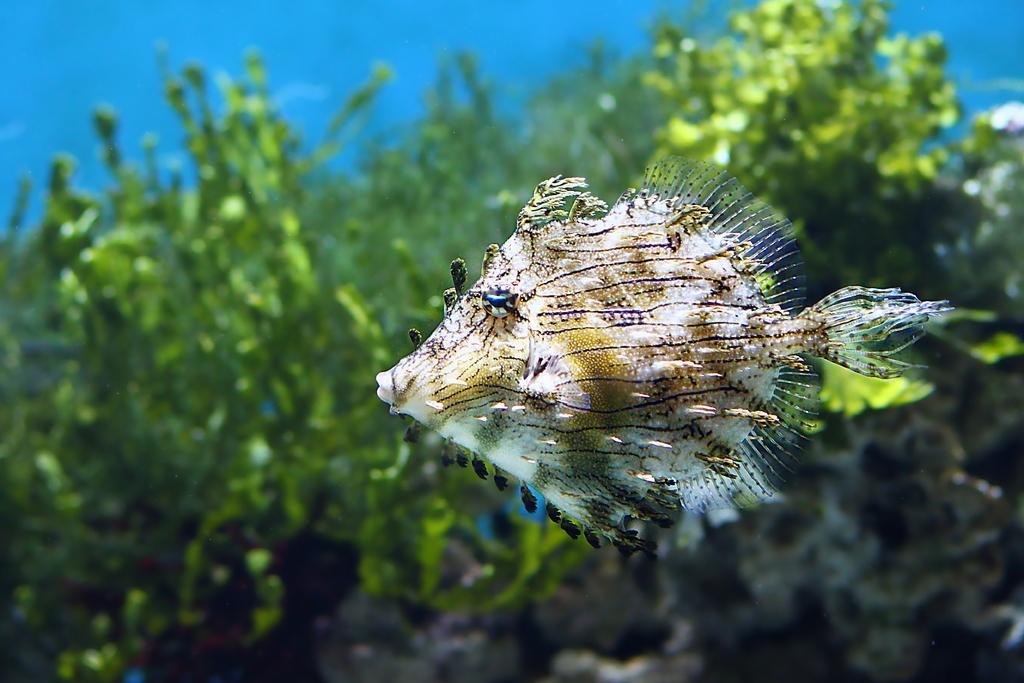In one or two sentences, can you explain what this image depicts? In the foreground of this image, there is a fish under the water. In the background, there are plants. 